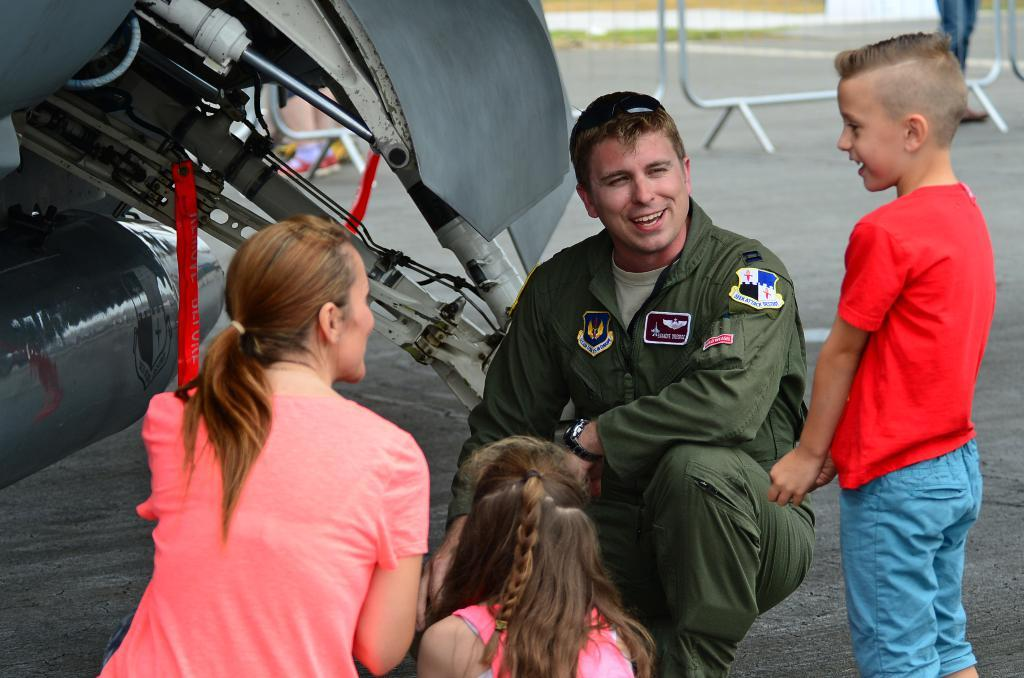How many adults are in the image? There are two adults in the image. Are there any children in the image? Yes, there are kids in the image. What is the general mood of the people in the image? The people in the image are smiling, which suggests a positive mood. What can be seen in the background of the image? There are objects visible in the background. What type of barrier is present in the image? There is a mesh fence in the image. Can you describe the position of one of the people in relation to the mesh fence? A person's leg is visible behind the mesh fence. What language is being spoken by the people in the image? The image does not provide any information about the language being spoken by the people. What discovery was made by the kids in the image? There is no indication of a discovery being made by the kids in the image. What is the zinc content of the mesh fence in the image? The image does not provide any information about the zinc content of the mesh fence. 